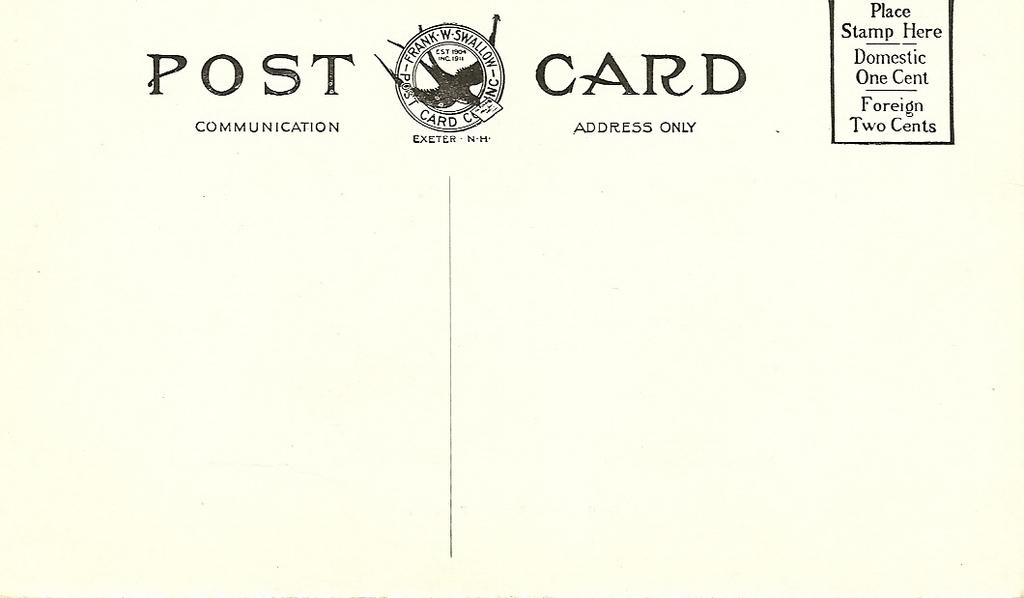<image>
Present a compact description of the photo's key features. A blank white postcard with a square in the top right corner showing to place stamp here. 